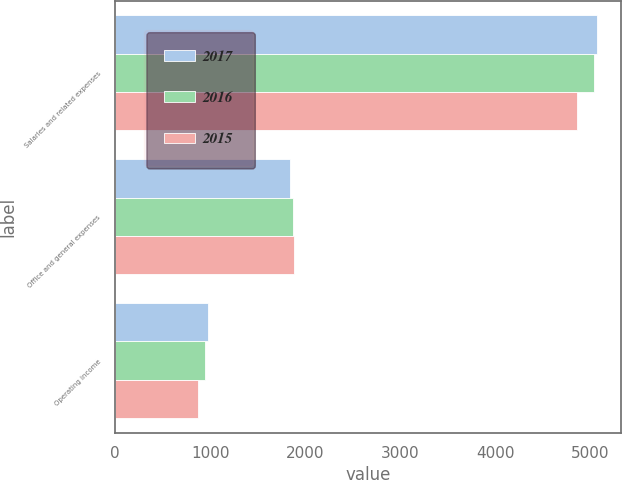Convert chart to OTSL. <chart><loc_0><loc_0><loc_500><loc_500><stacked_bar_chart><ecel><fcel>Salaries and related expenses<fcel>Office and general expenses<fcel>Operating income<nl><fcel>2017<fcel>5068.1<fcel>1840.7<fcel>973.6<nl><fcel>2016<fcel>5035.1<fcel>1870.5<fcel>941<nl><fcel>2015<fcel>4854.8<fcel>1884.2<fcel>874.8<nl></chart> 